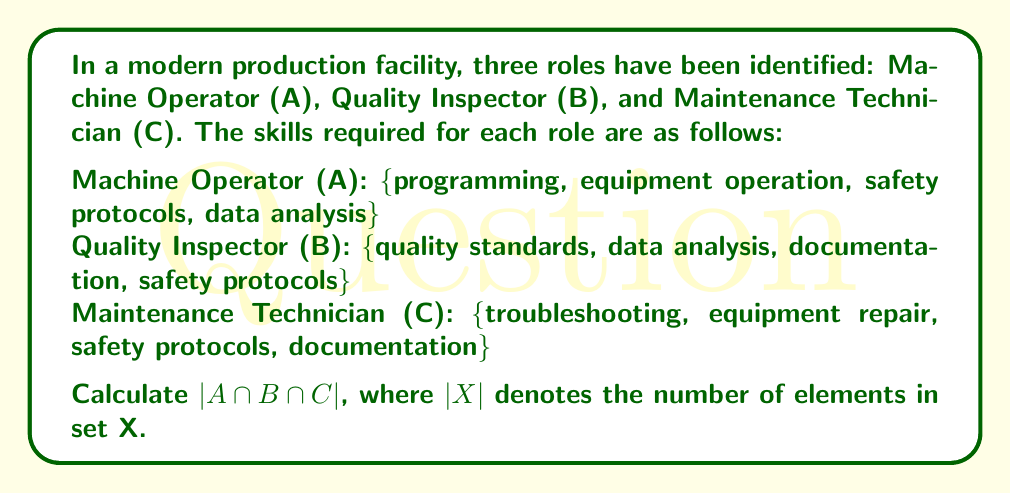Can you answer this question? To solve this problem, we need to find the intersection of all three sets and then count the number of elements in this intersection. Let's approach this step-by-step:

1. First, let's identify the elements that are common to all three sets:

   A = {programming, equipment operation, safety protocols, data analysis}
   B = {quality standards, data analysis, documentation, safety protocols}
   C = {troubleshooting, equipment repair, safety protocols, documentation}

2. We can see that "safety protocols" is the only skill that appears in all three sets.

3. The intersection of all three sets can be written as:

   $A \cap B \cap C = \text{\{safety protocols\}}$

4. To calculate $|A \cap B \cap C|$, we simply need to count the number of elements in this intersection.

5. The intersection contains only one element: "safety protocols".

Therefore, $|A \cap B \cap C| = 1$.

This result indicates that safety protocols is the one skill that is universally required across all three production roles, highlighting its critical importance in the modern production environment.
Answer: $|A \cap B \cap C| = 1$ 